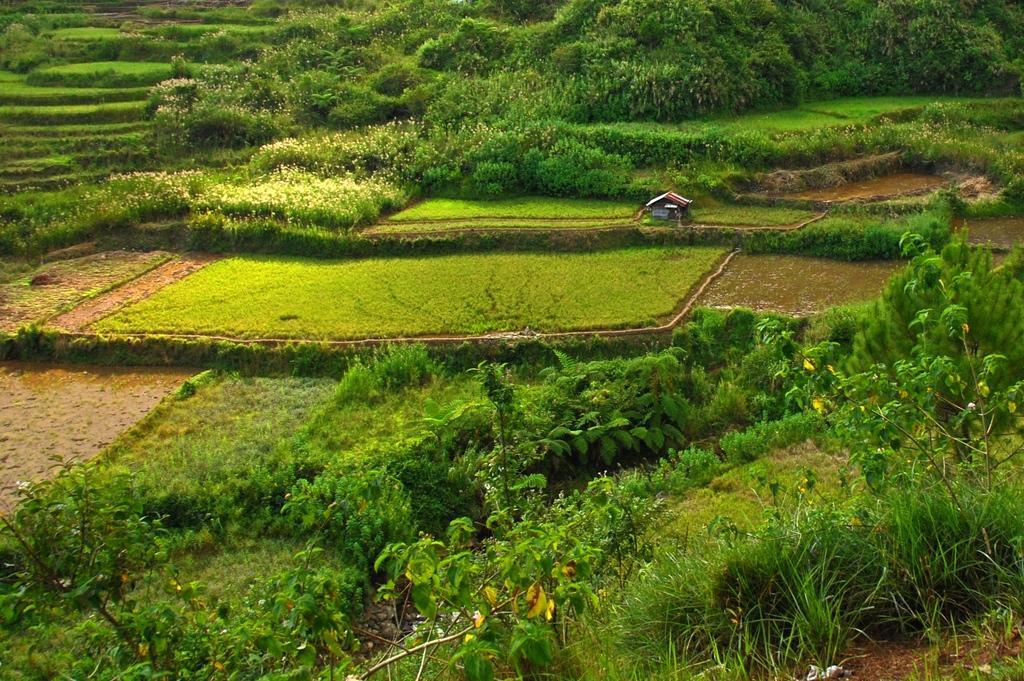How would you summarize this image in a sentence or two? In this image we can see trees, plants and house. 